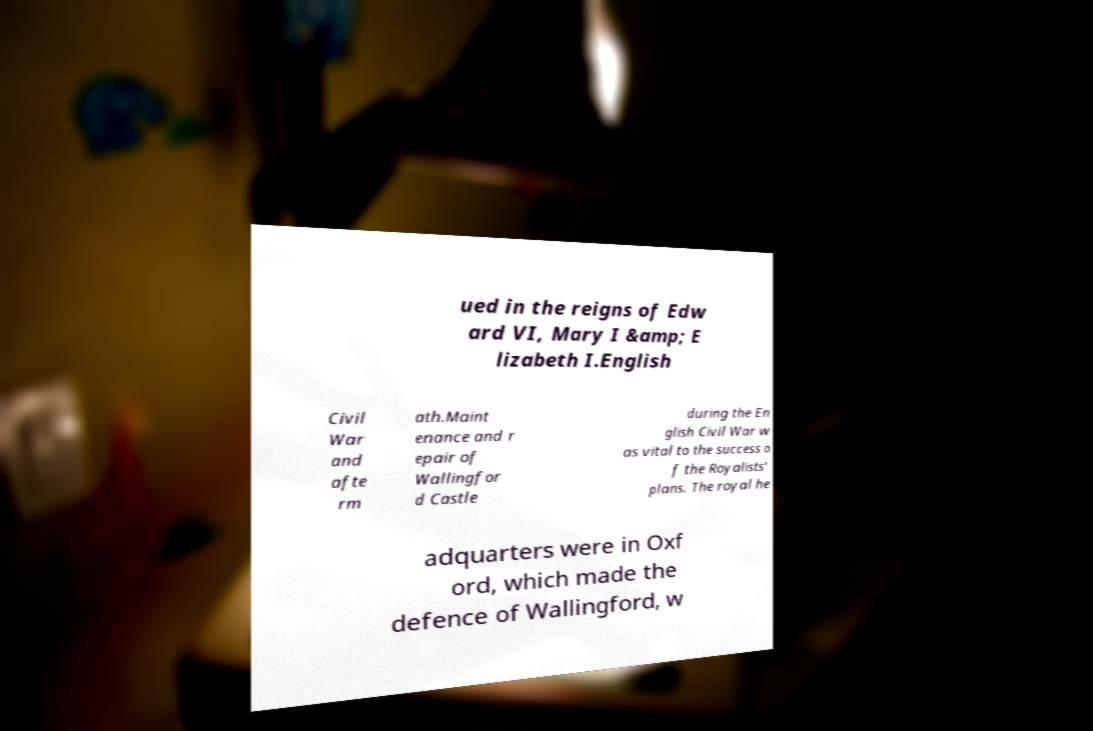There's text embedded in this image that I need extracted. Can you transcribe it verbatim? ued in the reigns of Edw ard VI, Mary I &amp; E lizabeth I.English Civil War and afte rm ath.Maint enance and r epair of Wallingfor d Castle during the En glish Civil War w as vital to the success o f the Royalists' plans. The royal he adquarters were in Oxf ord, which made the defence of Wallingford, w 